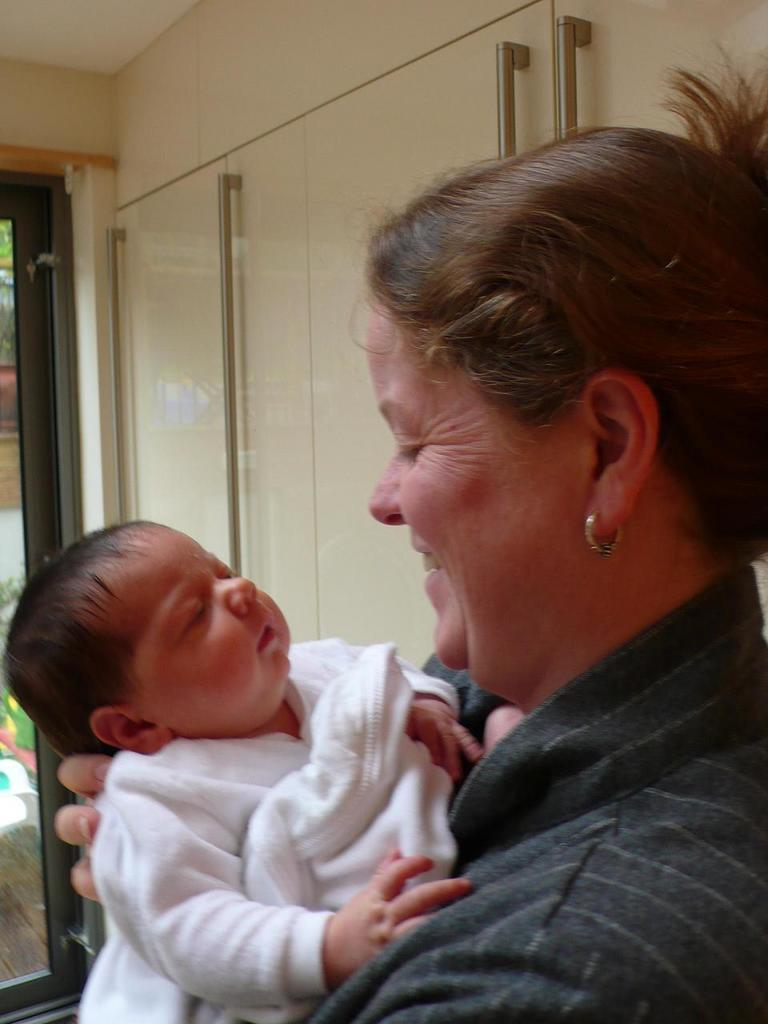Who is the main subject in the image? There is a woman in the image. What is the woman doing in the image? The woman is carrying a baby. What can be seen in the background of the image? There is a wall with metal poles in the image. Is there any entrance or exit visible in the image? Yes, there is a door in the image. Can you tell me how many people are swimming in the image? There is no swimming activity depicted in the image. What type of park can be seen in the image? There is no park present in the image. 